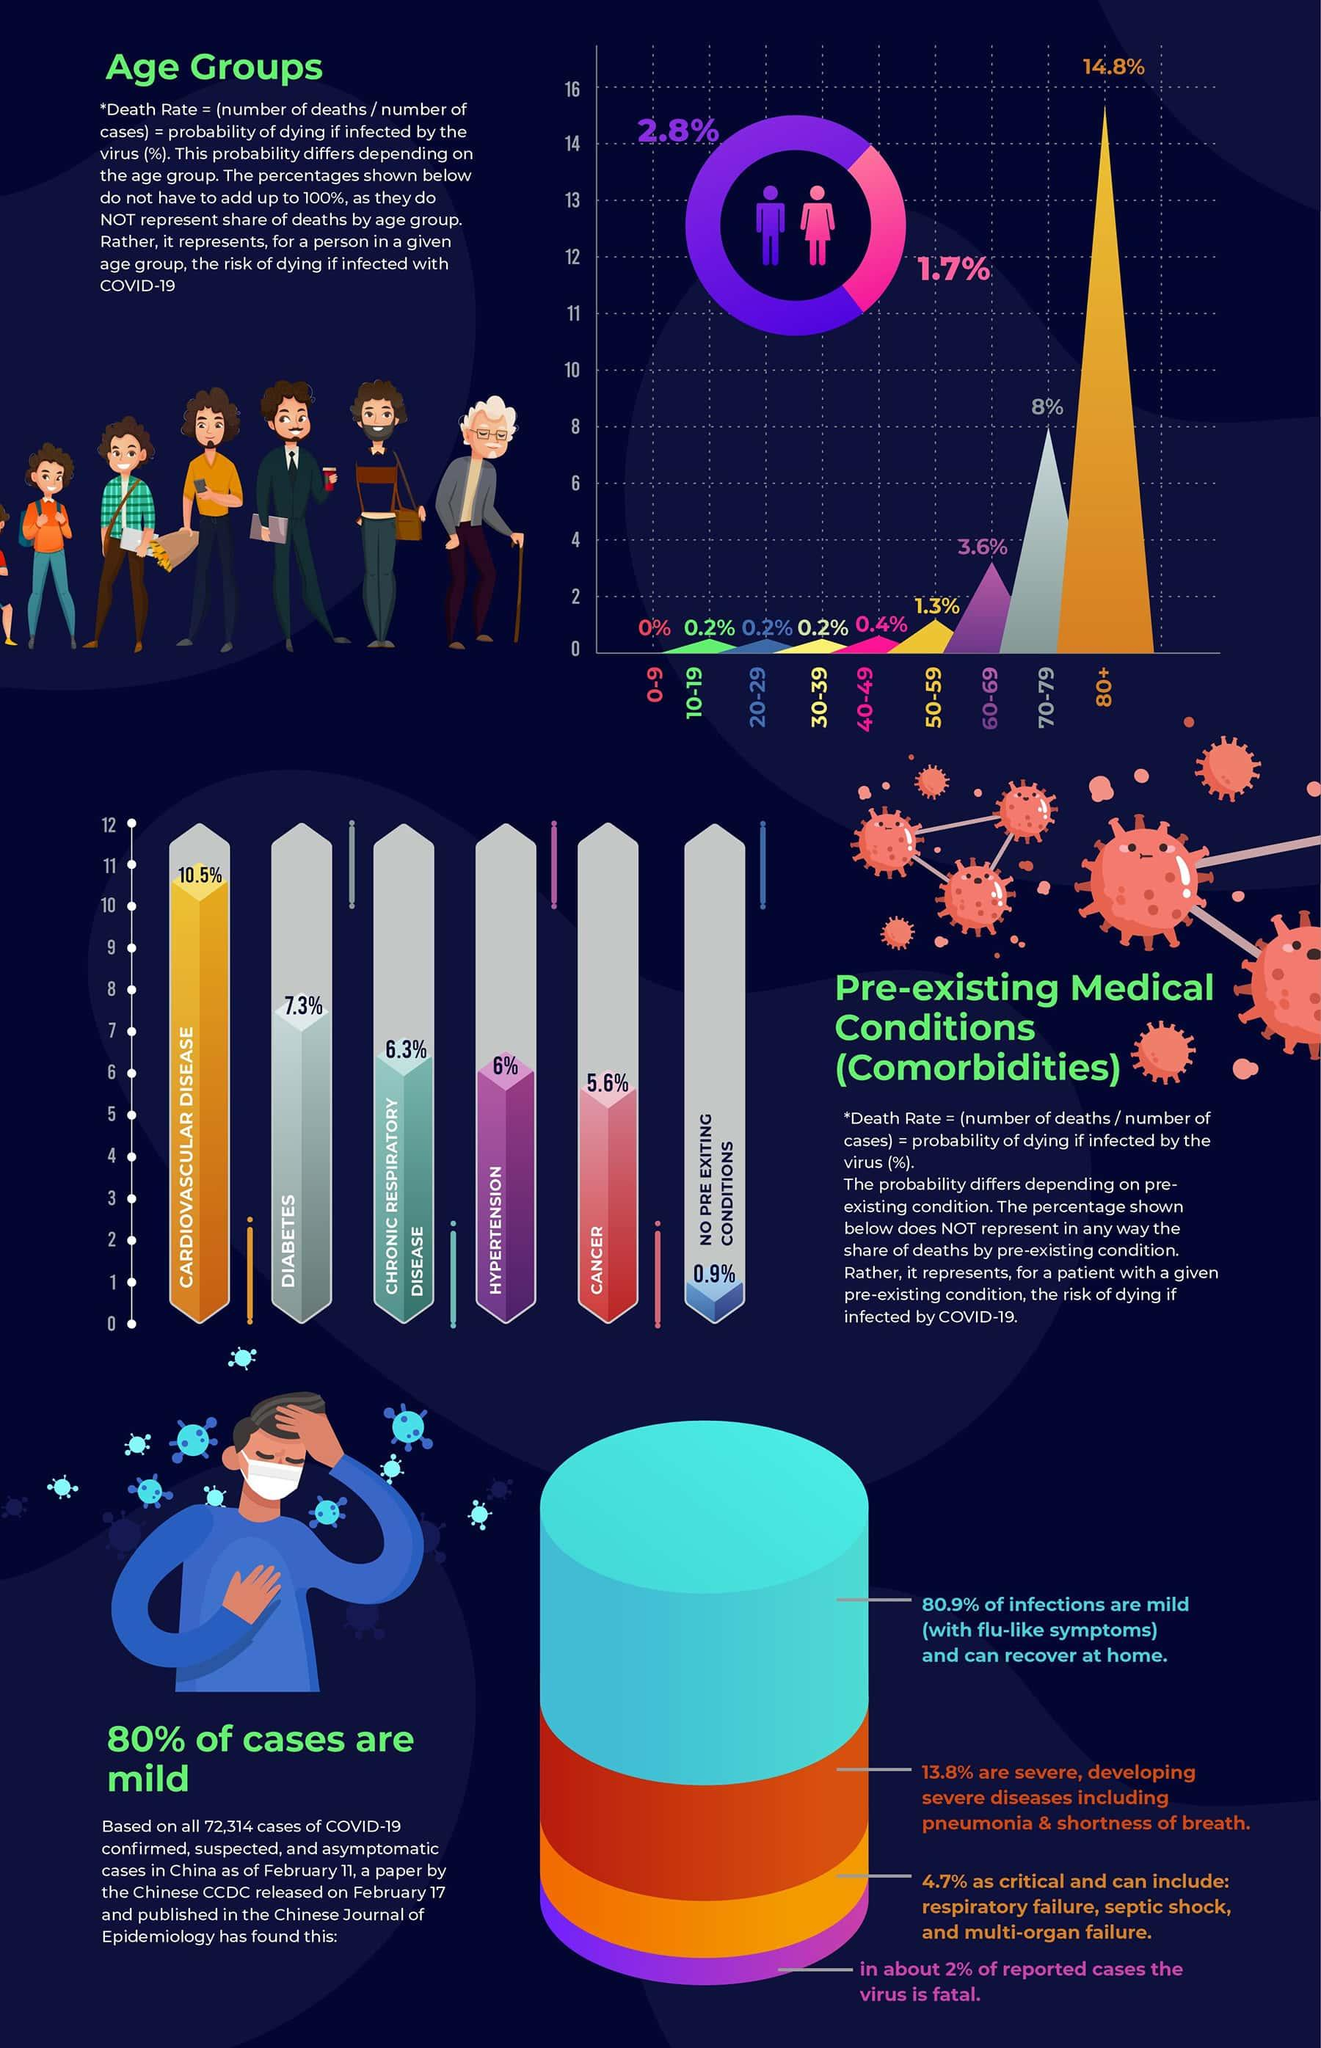Mention a couple of crucial points in this snapshot. Based on available data, it is estimated that only 0.2% of individuals in the age group of 20-29 years old are at risk of dying from COVID-19. Cardiovascular disease accounts for 10.5% of all deaths. According to a recent study, 2.8% of males are at risk of dying from infections. A recent study found that hypertension and cancer together account for 11.6% of all deaths worldwide. Chronic respiratory disease is a pre-existing condition that is a leading cause of death, accounting for 6.3% of all deaths. 